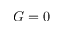Convert formula to latex. <formula><loc_0><loc_0><loc_500><loc_500>G = 0</formula> 